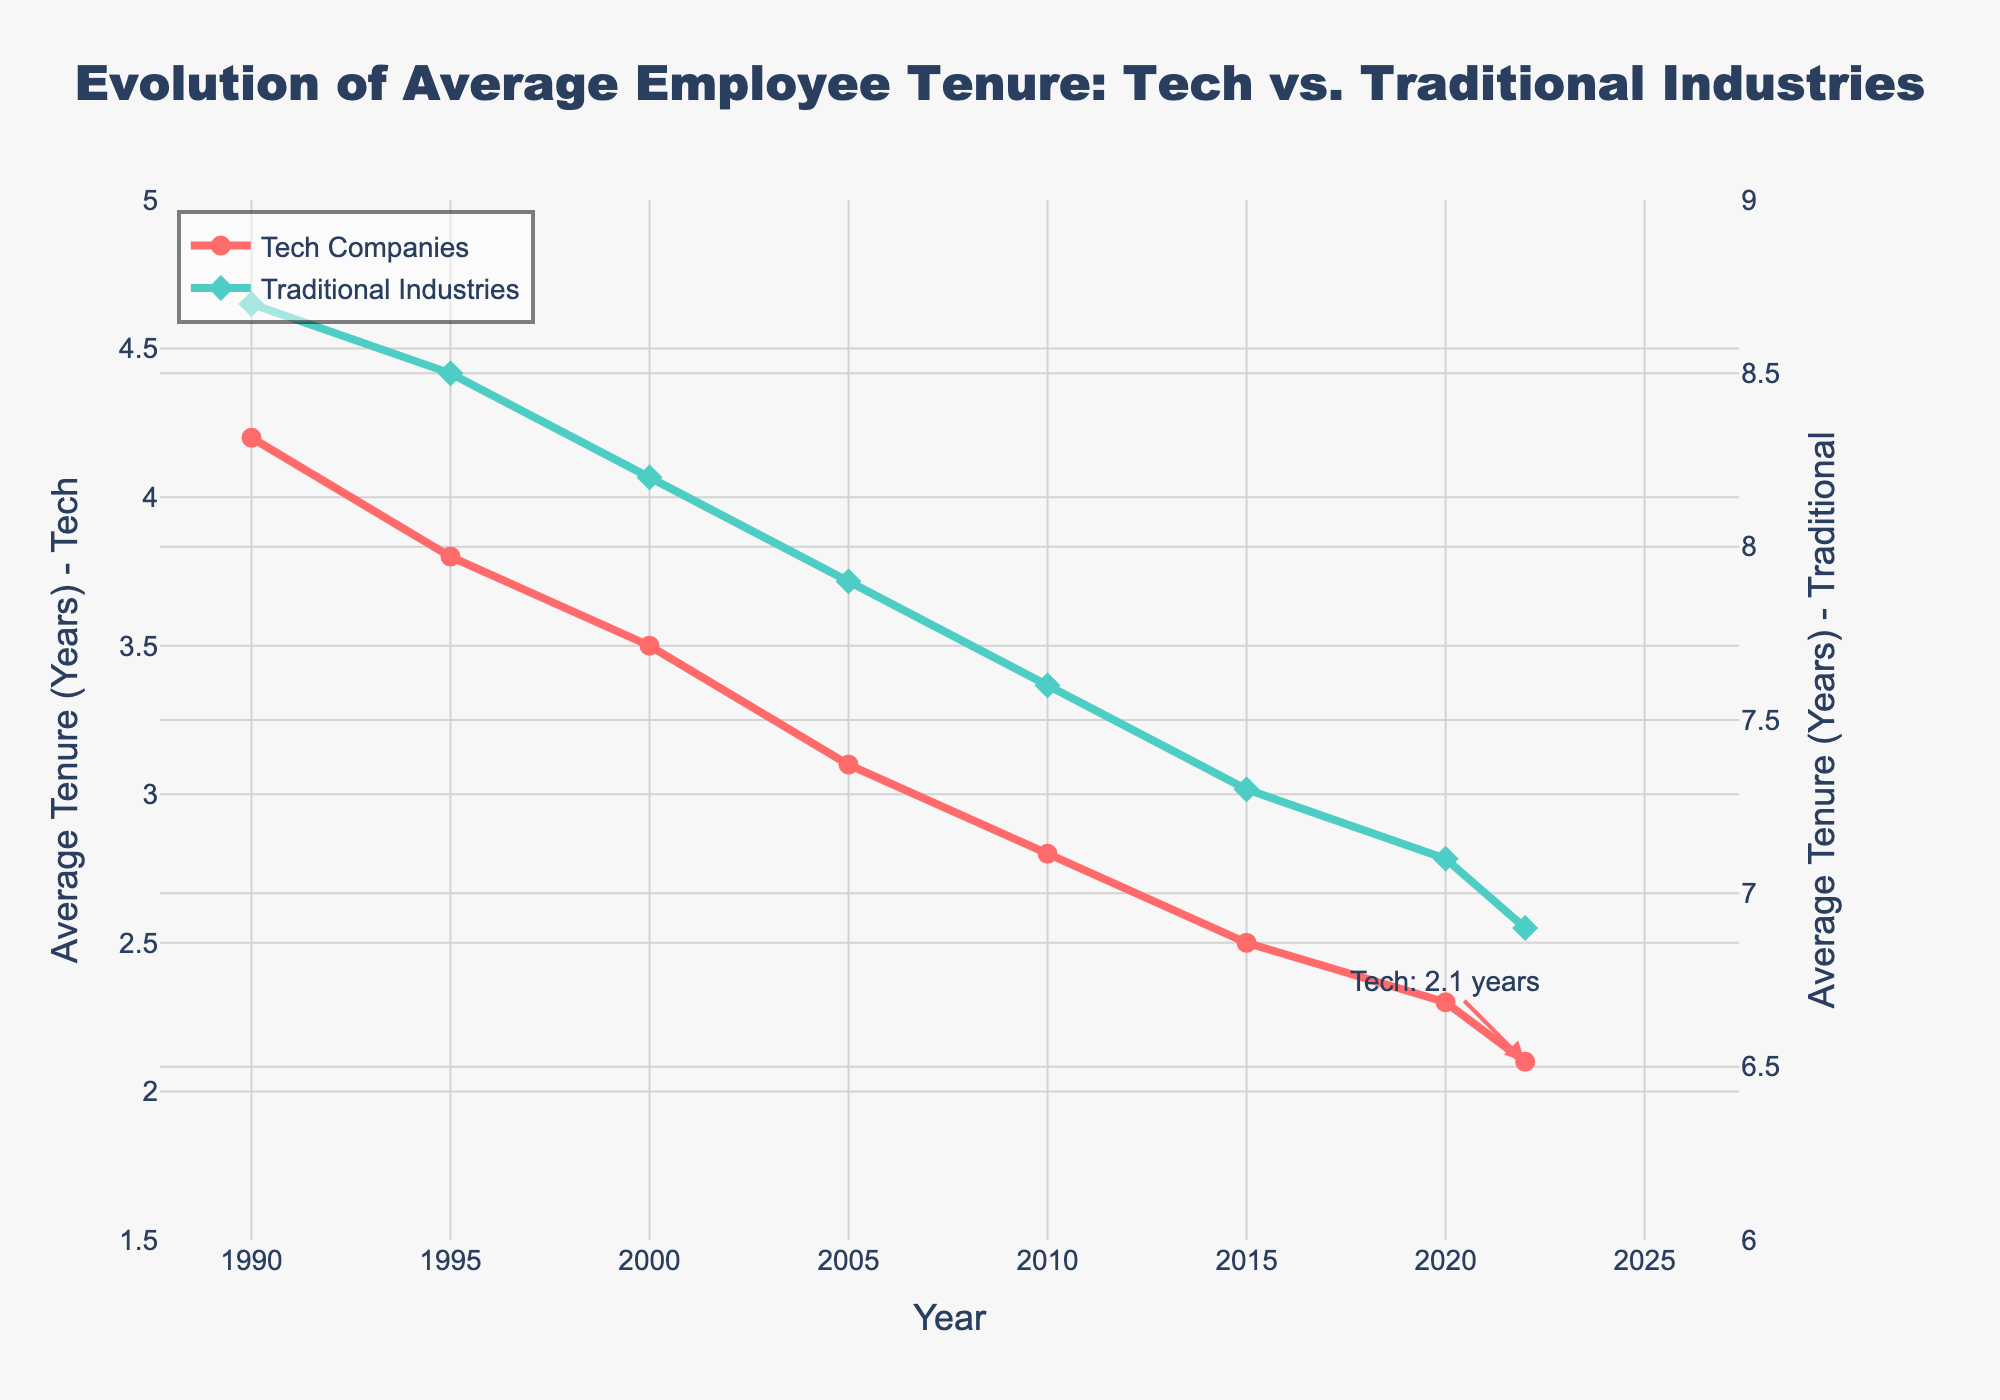What trend can be observed in the tenure of employees in tech companies from 1990 to 2022? The average tenure of employees in tech companies has been steadily decreasing from 4.2 years in 1990 to 2.1 years in 2022. This can be observed by noting how the line for tech companies consistently trends downward over the years.
Answer: The average tenure has been decreasing How does the tenure of employees in traditional industries in 2020 compare to tech companies in the same year? In 2020, the tenure of employees in traditional industries is 7.1 years, which is significantly higher than the 2.3 years observed in tech companies. You can see this by comparing the two data points for 2020 on the graph.
Answer: Traditional industries (7.1 years) are much higher than tech companies (2.3 years) What is the difference between employee tenure in traditional industries and tech companies in 1990? The difference is calculated by subtracting the tenure in tech companies from the tenure in traditional industries. So, 8.7 years (traditional) - 4.2 years (tech) = 4.5 years.
Answer: 4.5 years Which industry shows a more significant decreasing trend in employee tenure over the years? By observing the slopes of the lines, the tech companies' tenure shows a more significant decreasing trend. This is evident as the tech line drops more steeply compared to the more gradual decline of the traditional industries' line.
Answer: Tech companies By how many years did the tenure in traditional industries decrease from 1990 to 2022? The decrease is found by subtracting the value in 2022 from the value in 1990. So, 8.7 years (1990) - 6.9 years (2022) = 1.8 years.
Answer: 1.8 years What can be inferred visually about the relative stability of employee tenure between tech companies and traditional industries? Visually, the line representing traditional industries is higher and flatter, indicating more consistent and longer employee tenure compared to the steeper and lower line of tech companies, indicating less stability in employee tenure.
Answer: Traditional industries show more stability Compare the rate of change in employee tenure for tech companies between 1990 and 2000 with that between 2010 and 2022. For 1990 to 2000, the change is 4.2 - 3.5 = 0.7 years over 10 years, resulting in a rate change of 0.07 years per year. For 2010 to 2022, the change is 2.8 - 2.1 = 0.7 years over 12 years, resulting in a rate change of approximately 0.058 years per year. The rate of change is slightly higher between 1990 and 2000.
Answer: 1990-2000 had a higher rate of change Which industry had a steeper decline in tenure between 2010 and 2015? By comparing the slopes of the lines between 2010 and 2015, the tech companies' line appears to have a steeper decline than the traditional industries' line, indicating a more rapid decrease in employee tenure for tech companies.
Answer: Tech companies What was the average employee tenure in tech companies over the entire period from 1990 to 2022? The average tenure is calculated by summing the tenures for each year and dividing by the number of years. (4.2 + 3.8 + 3.5 + 3.1 + 2.8 + 2.5 + 2.3 + 2.1) / 8 = 24.3 / 8 = 3.0375 years.
Answer: 3.04 years How does the difference in tenure between traditional industries and tech companies evolve over the years? The difference decreases over time. In 1990, the difference is 8.7 - 4.2 = 4.5 years; by 2022, it is 6.9 - 2.1 = 4.8 years. Although the absolute gap seems larger in terms of visual comparison, the decreasing trend in both lines shows a converging pattern.
Answer: The difference decreases over time 